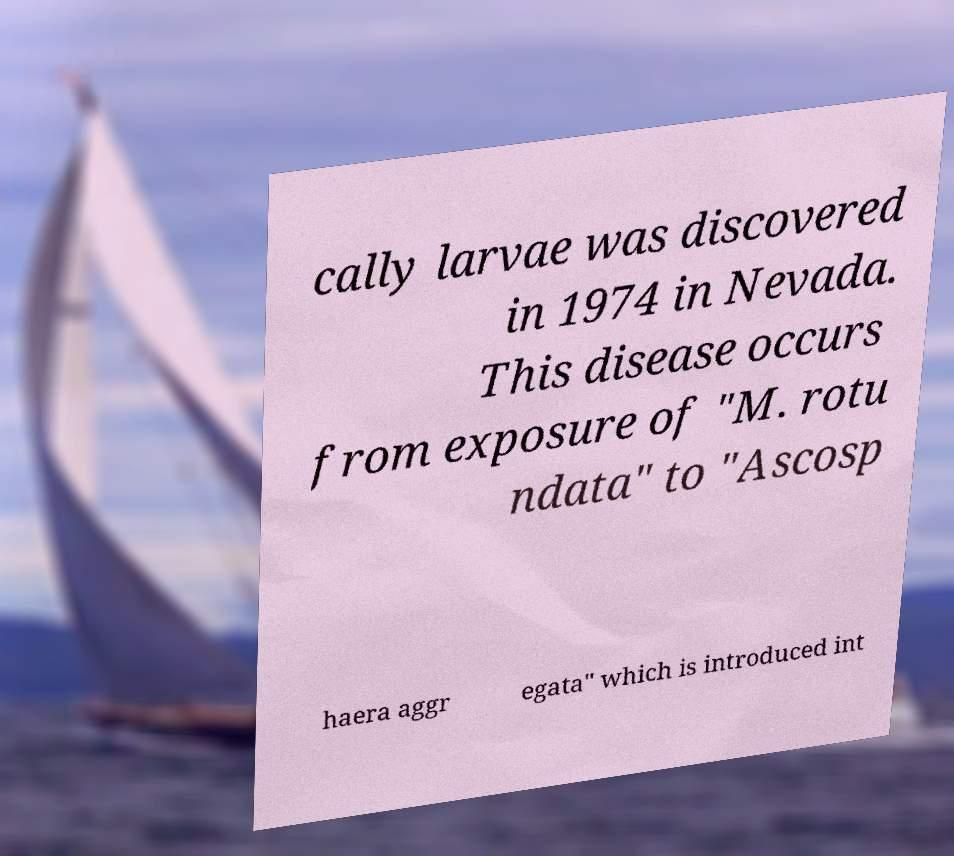Please identify and transcribe the text found in this image. cally larvae was discovered in 1974 in Nevada. This disease occurs from exposure of "M. rotu ndata" to "Ascosp haera aggr egata" which is introduced int 